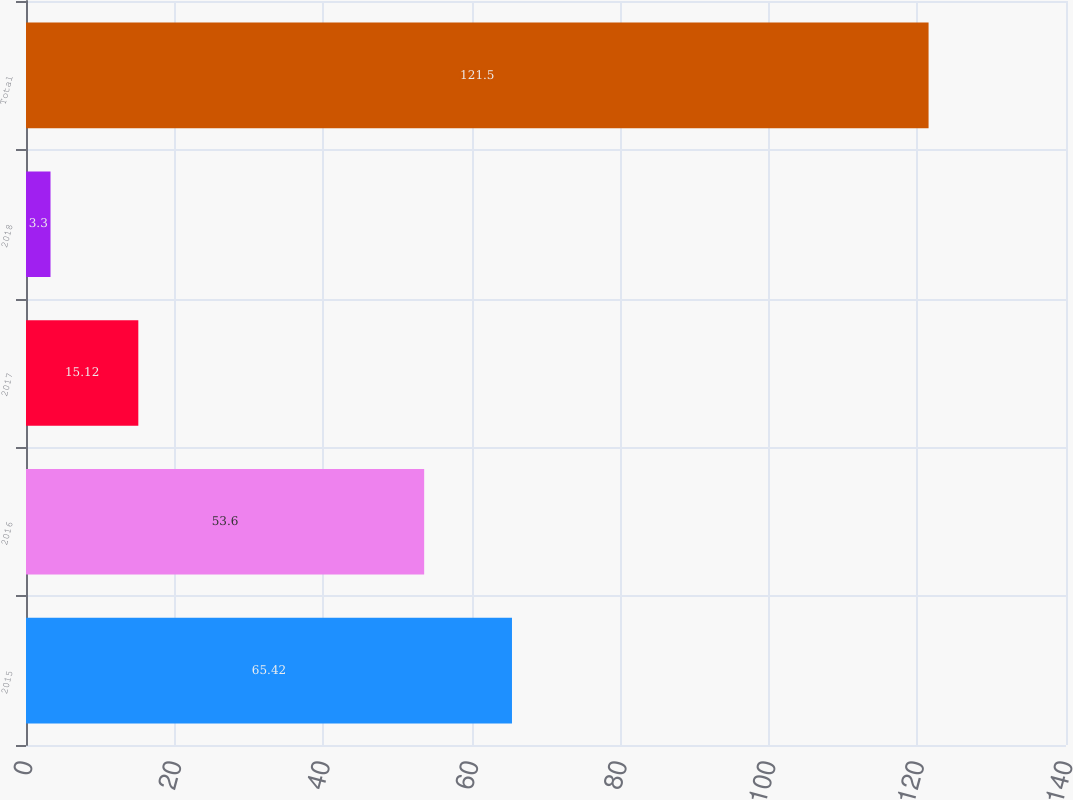Convert chart to OTSL. <chart><loc_0><loc_0><loc_500><loc_500><bar_chart><fcel>2015<fcel>2016<fcel>2017<fcel>2018<fcel>Total<nl><fcel>65.42<fcel>53.6<fcel>15.12<fcel>3.3<fcel>121.5<nl></chart> 